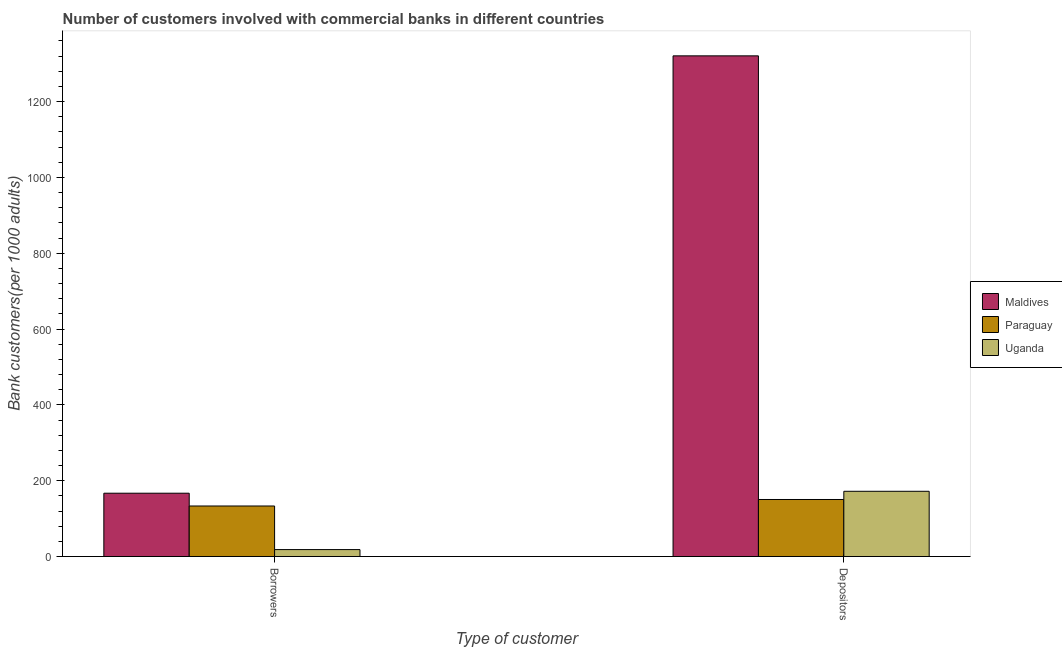How many groups of bars are there?
Your response must be concise. 2. What is the label of the 1st group of bars from the left?
Make the answer very short. Borrowers. What is the number of borrowers in Paraguay?
Ensure brevity in your answer.  133.32. Across all countries, what is the maximum number of borrowers?
Ensure brevity in your answer.  167.07. Across all countries, what is the minimum number of borrowers?
Make the answer very short. 18.33. In which country was the number of borrowers maximum?
Offer a terse response. Maldives. In which country was the number of borrowers minimum?
Keep it short and to the point. Uganda. What is the total number of depositors in the graph?
Keep it short and to the point. 1643.27. What is the difference between the number of borrowers in Paraguay and that in Maldives?
Make the answer very short. -33.75. What is the difference between the number of borrowers in Maldives and the number of depositors in Paraguay?
Provide a succinct answer. 16.6. What is the average number of depositors per country?
Ensure brevity in your answer.  547.76. What is the difference between the number of borrowers and number of depositors in Uganda?
Provide a short and direct response. -153.77. In how many countries, is the number of depositors greater than 840 ?
Offer a very short reply. 1. What is the ratio of the number of depositors in Maldives to that in Paraguay?
Ensure brevity in your answer.  8.78. What does the 1st bar from the left in Depositors represents?
Offer a terse response. Maldives. What does the 3rd bar from the right in Borrowers represents?
Your answer should be compact. Maldives. How many bars are there?
Make the answer very short. 6. How many countries are there in the graph?
Offer a very short reply. 3. Are the values on the major ticks of Y-axis written in scientific E-notation?
Ensure brevity in your answer.  No. Does the graph contain grids?
Your response must be concise. No. Where does the legend appear in the graph?
Keep it short and to the point. Center right. How many legend labels are there?
Keep it short and to the point. 3. What is the title of the graph?
Provide a succinct answer. Number of customers involved with commercial banks in different countries. What is the label or title of the X-axis?
Your answer should be very brief. Type of customer. What is the label or title of the Y-axis?
Your answer should be very brief. Bank customers(per 1000 adults). What is the Bank customers(per 1000 adults) in Maldives in Borrowers?
Your response must be concise. 167.07. What is the Bank customers(per 1000 adults) in Paraguay in Borrowers?
Offer a terse response. 133.32. What is the Bank customers(per 1000 adults) of Uganda in Borrowers?
Provide a short and direct response. 18.33. What is the Bank customers(per 1000 adults) of Maldives in Depositors?
Your answer should be very brief. 1320.69. What is the Bank customers(per 1000 adults) of Paraguay in Depositors?
Make the answer very short. 150.47. What is the Bank customers(per 1000 adults) of Uganda in Depositors?
Give a very brief answer. 172.11. Across all Type of customer, what is the maximum Bank customers(per 1000 adults) in Maldives?
Ensure brevity in your answer.  1320.69. Across all Type of customer, what is the maximum Bank customers(per 1000 adults) in Paraguay?
Give a very brief answer. 150.47. Across all Type of customer, what is the maximum Bank customers(per 1000 adults) in Uganda?
Your response must be concise. 172.11. Across all Type of customer, what is the minimum Bank customers(per 1000 adults) in Maldives?
Keep it short and to the point. 167.07. Across all Type of customer, what is the minimum Bank customers(per 1000 adults) of Paraguay?
Ensure brevity in your answer.  133.32. Across all Type of customer, what is the minimum Bank customers(per 1000 adults) in Uganda?
Your answer should be very brief. 18.33. What is the total Bank customers(per 1000 adults) of Maldives in the graph?
Make the answer very short. 1487.76. What is the total Bank customers(per 1000 adults) of Paraguay in the graph?
Offer a very short reply. 283.79. What is the total Bank customers(per 1000 adults) of Uganda in the graph?
Your response must be concise. 190.44. What is the difference between the Bank customers(per 1000 adults) of Maldives in Borrowers and that in Depositors?
Your answer should be compact. -1153.63. What is the difference between the Bank customers(per 1000 adults) in Paraguay in Borrowers and that in Depositors?
Your answer should be very brief. -17.15. What is the difference between the Bank customers(per 1000 adults) of Uganda in Borrowers and that in Depositors?
Provide a succinct answer. -153.77. What is the difference between the Bank customers(per 1000 adults) in Maldives in Borrowers and the Bank customers(per 1000 adults) in Paraguay in Depositors?
Provide a succinct answer. 16.6. What is the difference between the Bank customers(per 1000 adults) in Maldives in Borrowers and the Bank customers(per 1000 adults) in Uganda in Depositors?
Your answer should be very brief. -5.04. What is the difference between the Bank customers(per 1000 adults) of Paraguay in Borrowers and the Bank customers(per 1000 adults) of Uganda in Depositors?
Provide a succinct answer. -38.79. What is the average Bank customers(per 1000 adults) of Maldives per Type of customer?
Your response must be concise. 743.88. What is the average Bank customers(per 1000 adults) in Paraguay per Type of customer?
Your answer should be compact. 141.89. What is the average Bank customers(per 1000 adults) in Uganda per Type of customer?
Offer a terse response. 95.22. What is the difference between the Bank customers(per 1000 adults) of Maldives and Bank customers(per 1000 adults) of Paraguay in Borrowers?
Offer a terse response. 33.75. What is the difference between the Bank customers(per 1000 adults) of Maldives and Bank customers(per 1000 adults) of Uganda in Borrowers?
Give a very brief answer. 148.73. What is the difference between the Bank customers(per 1000 adults) in Paraguay and Bank customers(per 1000 adults) in Uganda in Borrowers?
Ensure brevity in your answer.  114.99. What is the difference between the Bank customers(per 1000 adults) of Maldives and Bank customers(per 1000 adults) of Paraguay in Depositors?
Provide a short and direct response. 1170.22. What is the difference between the Bank customers(per 1000 adults) of Maldives and Bank customers(per 1000 adults) of Uganda in Depositors?
Make the answer very short. 1148.59. What is the difference between the Bank customers(per 1000 adults) in Paraguay and Bank customers(per 1000 adults) in Uganda in Depositors?
Your answer should be very brief. -21.64. What is the ratio of the Bank customers(per 1000 adults) in Maldives in Borrowers to that in Depositors?
Ensure brevity in your answer.  0.13. What is the ratio of the Bank customers(per 1000 adults) of Paraguay in Borrowers to that in Depositors?
Ensure brevity in your answer.  0.89. What is the ratio of the Bank customers(per 1000 adults) in Uganda in Borrowers to that in Depositors?
Give a very brief answer. 0.11. What is the difference between the highest and the second highest Bank customers(per 1000 adults) in Maldives?
Offer a very short reply. 1153.63. What is the difference between the highest and the second highest Bank customers(per 1000 adults) in Paraguay?
Ensure brevity in your answer.  17.15. What is the difference between the highest and the second highest Bank customers(per 1000 adults) of Uganda?
Your response must be concise. 153.77. What is the difference between the highest and the lowest Bank customers(per 1000 adults) in Maldives?
Give a very brief answer. 1153.63. What is the difference between the highest and the lowest Bank customers(per 1000 adults) in Paraguay?
Your answer should be compact. 17.15. What is the difference between the highest and the lowest Bank customers(per 1000 adults) in Uganda?
Your answer should be compact. 153.77. 